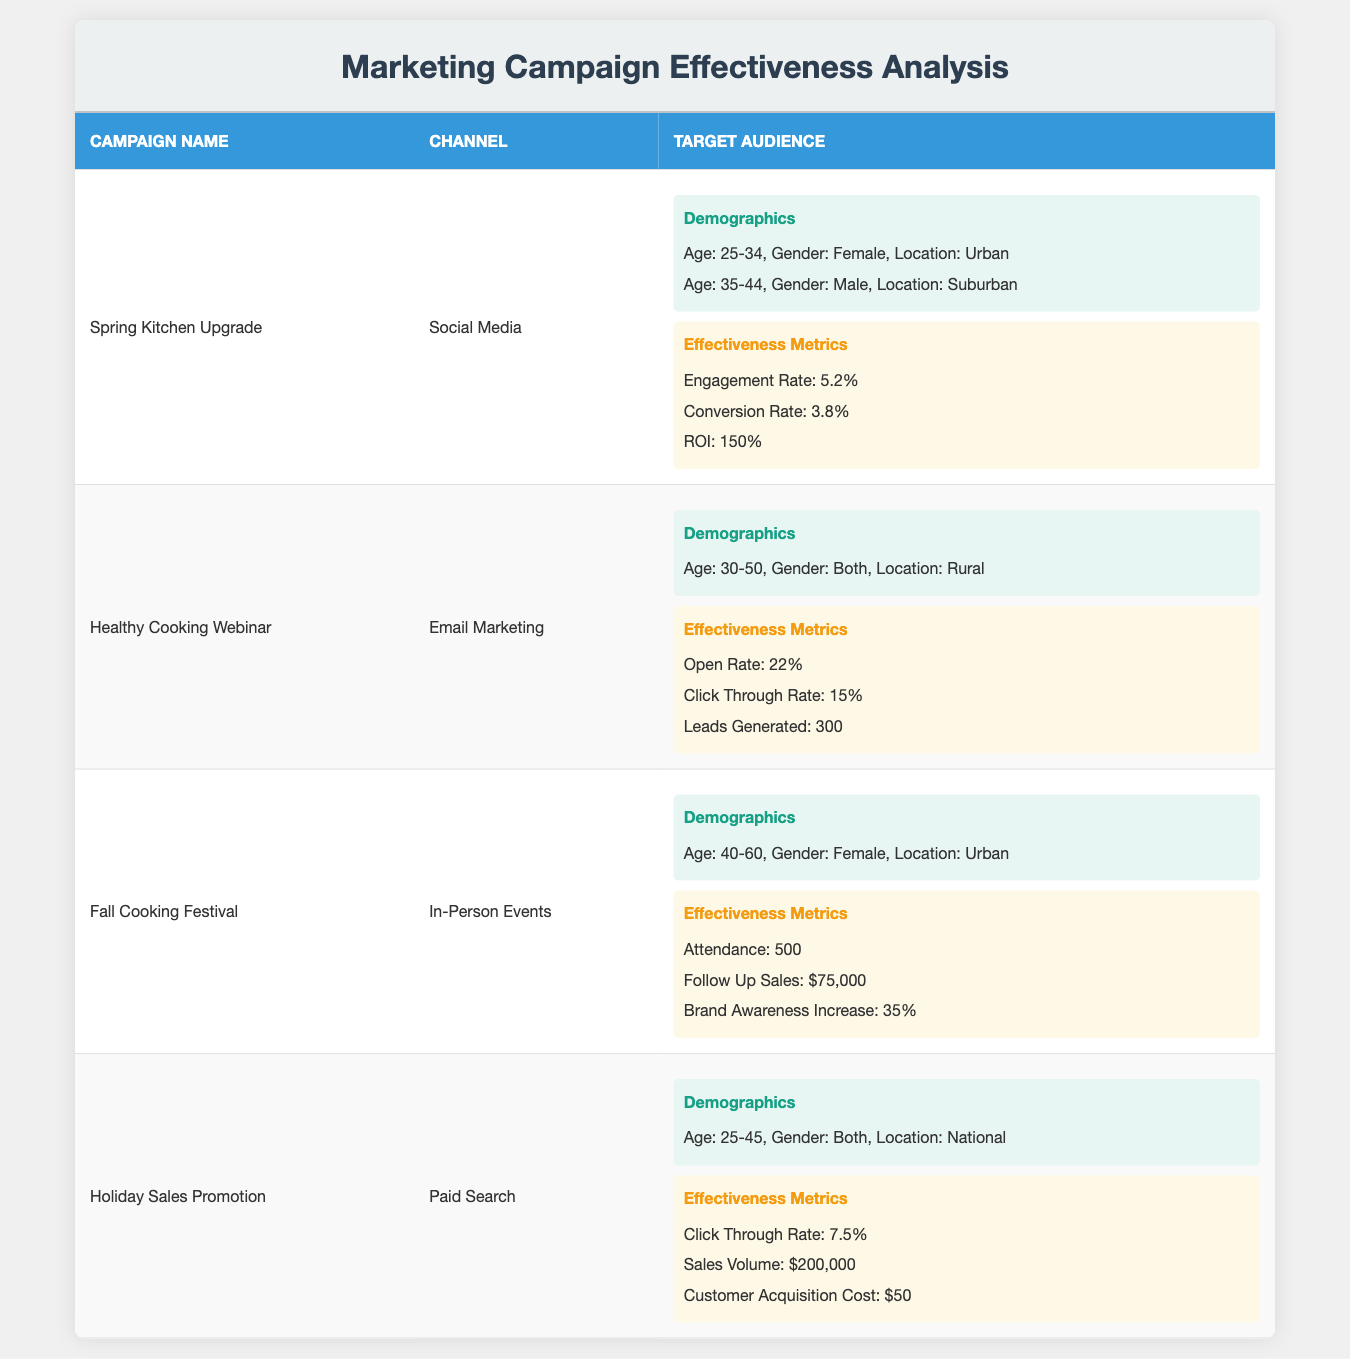What is the engagement rate for the Spring Kitchen Upgrade campaign? The engagement rate is listed under the effectiveness metrics for the Spring Kitchen Upgrade campaign. It is specified as 5.2%.
Answer: 5.2% What is the total attendance from the Fall Cooking Festival and the Healthy Cooking Webinar? The attendance for Fall Cooking Festival is 500, and the Healthy Cooking Webinar does not list attendance but instead focuses on leads generated. Since only Fall Cooking Festival provides attendance, the total is just 500.
Answer: 500 Is the open rate for the Healthy Cooking Webinar greater than the click-through rate for the Holiday Sales Promotion? The open rate for the Healthy Cooking Webinar is 22% and the click-through rate for the Holiday Sales Promotion is 7.5%. Since 22% is greater than 7.5%, the statement is true.
Answer: Yes Which campaign generated the highest sales volume? The Holiday Sales Promotion campaign lists the highest sales volume at $200,000 compared to the follow-up sales from the Fall Cooking Festival, which is $75,000.
Answer: $200,000 What is the average customer acquisition cost for the campaigns listed? The only campaign that provides a customer acquisition cost is the Holiday Sales Promotion, which is $50. Since there's only one value, the average is also $50.
Answer: $50 Did more males or females attend the Fall Cooking Festival? The Fall Cooking Festival targeted females aged 40-60. Based on the demographics provided, there were no males mentioned for this campaign. Therefore, only females attended this campaign.
Answer: Females What is the ROI percentage for the Spring Kitchen Upgrade campaign? The ROI for the Spring Kitchen Upgrade campaign is provided in the effectiveness metrics section and is stated as 150%.
Answer: 150% Which campaign had the highest engagement rate? Comparing engagement rates: the Spring Kitchen Upgrade has an engagement rate of 5.2%. Other campaigns do not list engagement rates, so 5.2% is the highest.
Answer: 5.2% What demographic locations were targeted in the Holiday Sales Promotion? The Holiday Sales Promotion targets a national audience based on the information provided in the demographics section.
Answer: National 